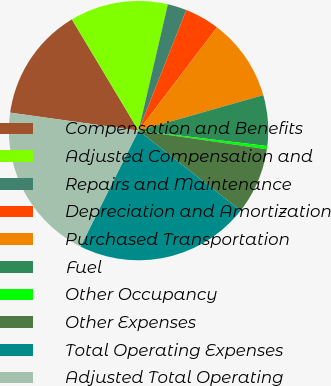Convert chart. <chart><loc_0><loc_0><loc_500><loc_500><pie_chart><fcel>Compensation and Benefits<fcel>Adjusted Compensation and<fcel>Repairs and Maintenance<fcel>Depreciation and Amortization<fcel>Purchased Transportation<fcel>Fuel<fcel>Other Occupancy<fcel>Other Expenses<fcel>Total Operating Expenses<fcel>Adjusted Total Operating<nl><fcel>14.19%<fcel>12.22%<fcel>2.37%<fcel>4.34%<fcel>10.25%<fcel>6.31%<fcel>0.4%<fcel>8.28%<fcel>21.8%<fcel>19.83%<nl></chart> 